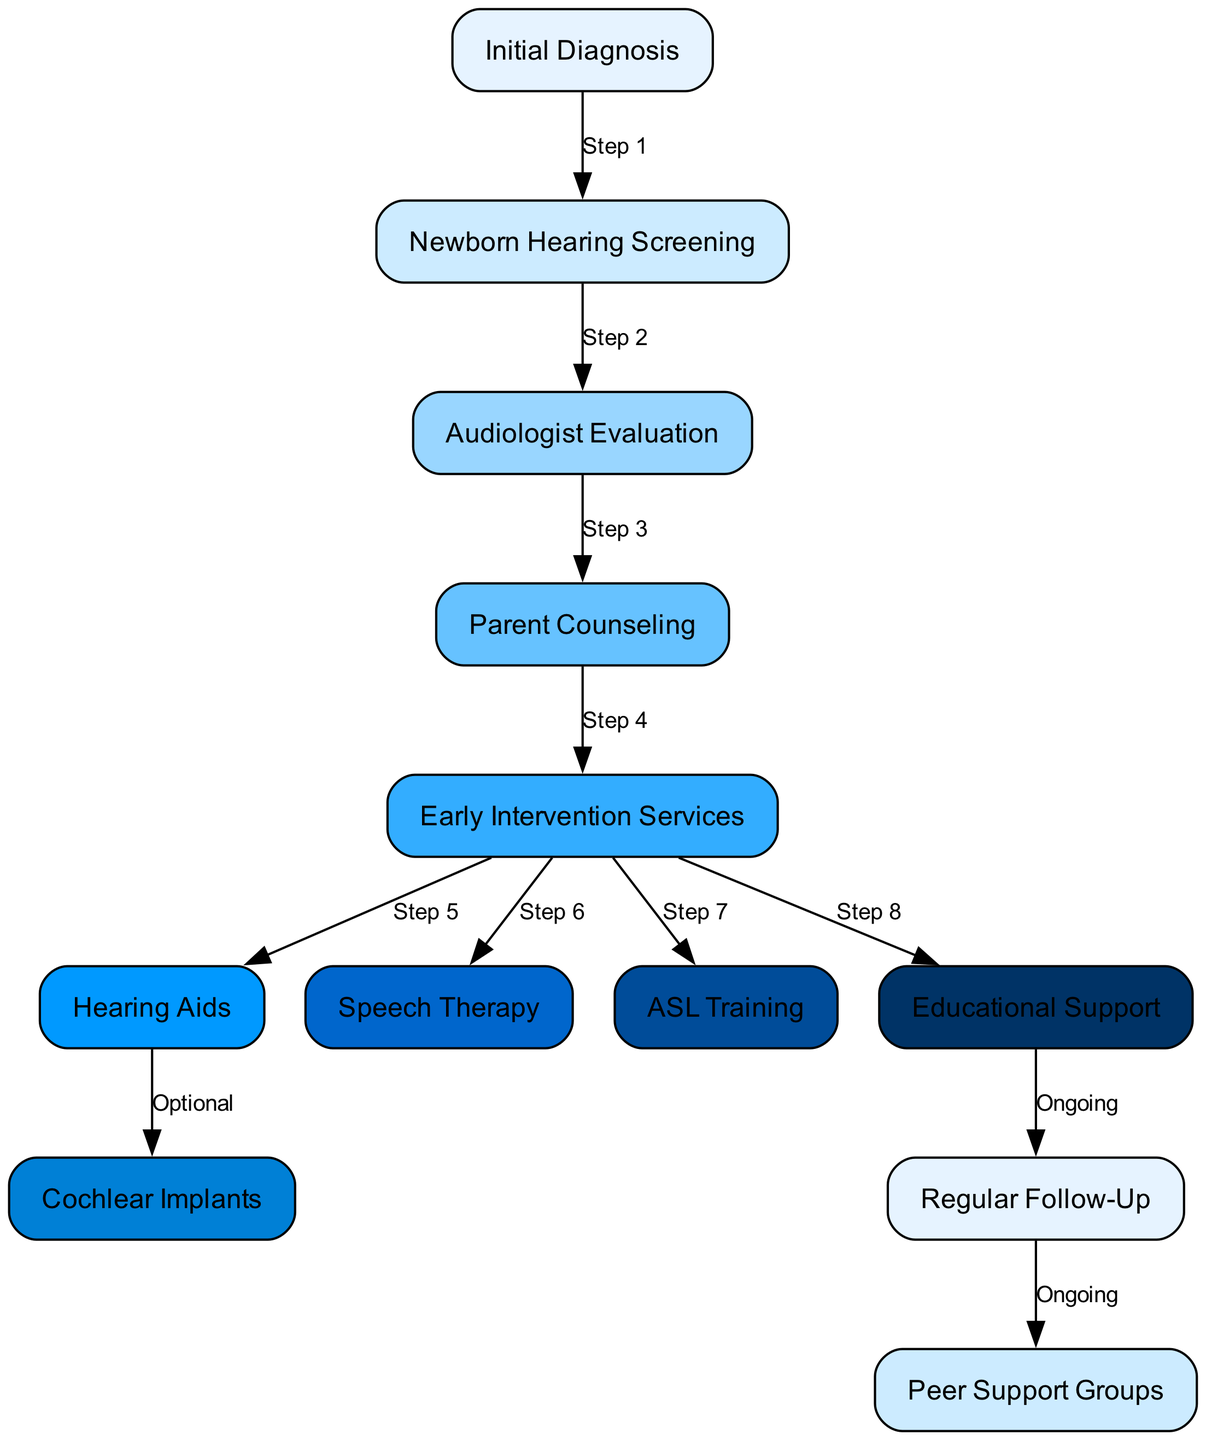What is the first step in the process? The diagram starts with "Initial Diagnosis," which is identified as the first node connected to the flow of steps
Answer: Initial Diagnosis How many nodes are present in the diagram? The diagram lists a total of 12 nodes, which can be counted directly from the node section of the data provided
Answer: 12 Which step follows the audiologist evaluation? The next step that follows "Audiologist Evaluation" is "Parent Counseling," connected by a directed edge labeled "Step 3"
Answer: Parent Counseling What is an optional step in this diagram? The diagram indicates that "Cochlear Implants" is an optional step, meaning it does not have to be taken after "Hearing Aids"
Answer: Cochlear Implants What is the final step that leads to ongoing support? The last node connected to "Regular Follow-Up" is "Peer Support Groups," which indicates ongoing support for families
Answer: Peer Support Groups How many steps are there between the initial diagnosis and hearing aids? The path includes 5 steps starting from "Initial Diagnosis" to "Newborn Hearing Screening," then to "Audiologist Evaluation," followed by "Parent Counseling," "Early Intervention Services," and finally leading to "Hearing Aids"
Answer: 5 Which type of training is provided during early intervention services? The diagram specifies two types of training provided during "Early Intervention Services," which are "ASL Training" and "Speech Therapy." Both are connected from the same node
Answer: ASL Training and Speech Therapy What connects educational support to regular follow-up? The transition from "Educational Support" to "Regular Follow-Up" is indicated as "Ongoing," signifying a continuous relationship for care and assessment
Answer: Ongoing Which step includes parent counseling? The step that includes "Parent Counseling" is directly after "Audiologist Evaluation," showing how crucial it is for the journey of care
Answer: Audiologist Evaluation 